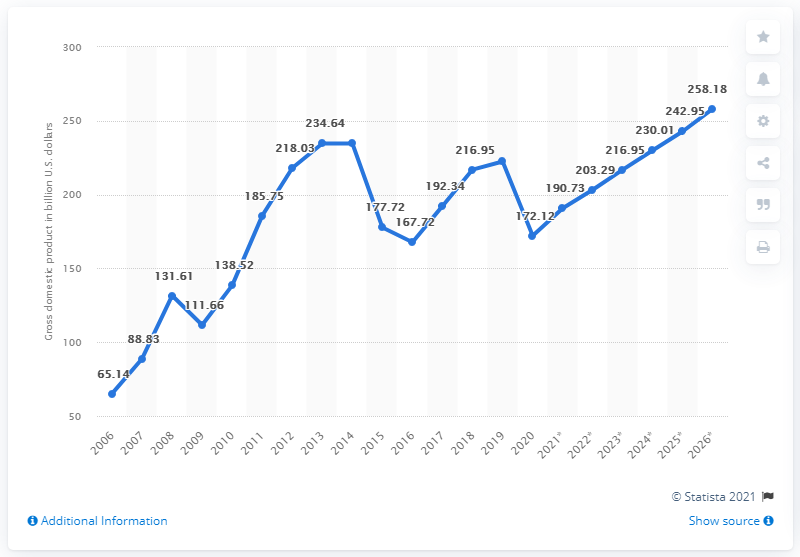What was Iraq's gross domestic product in dollars in 2020? In 2020, Iraq's gross domestic product was approximately 172 billion U.S. dollars, according to the data provided in the graph. This figure represents a noticeable decline from the previous year, illustrating the economic challenges the country faced during that period. 